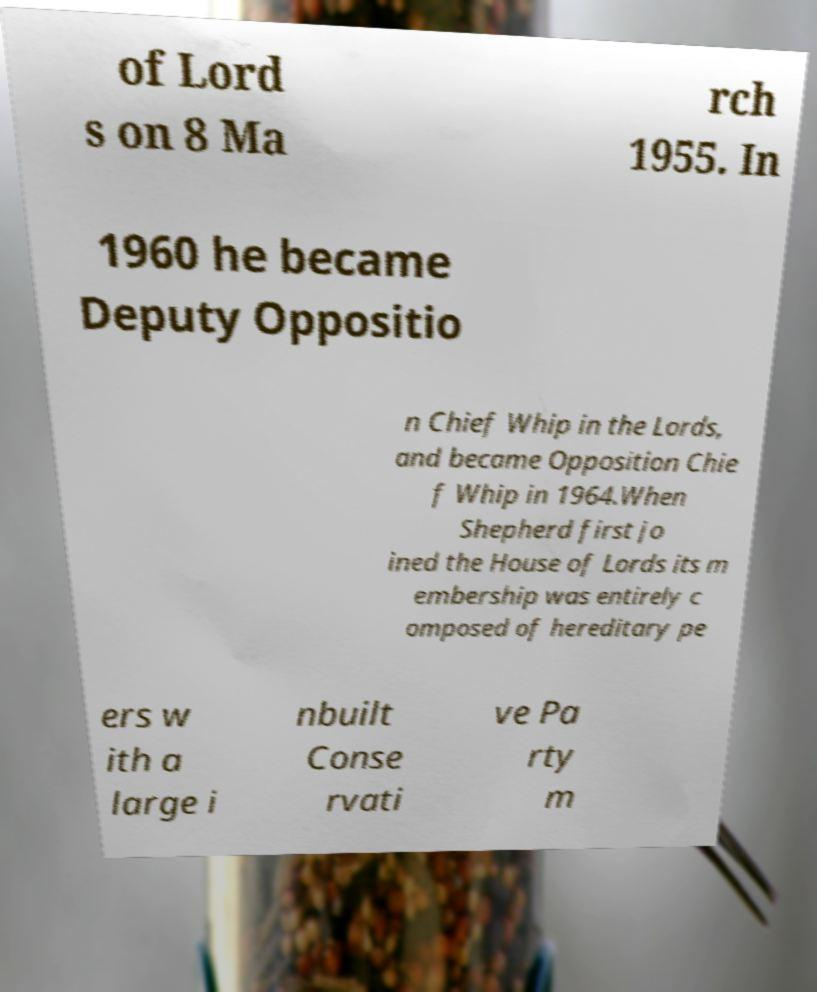Please read and relay the text visible in this image. What does it say? of Lord s on 8 Ma rch 1955. In 1960 he became Deputy Oppositio n Chief Whip in the Lords, and became Opposition Chie f Whip in 1964.When Shepherd first jo ined the House of Lords its m embership was entirely c omposed of hereditary pe ers w ith a large i nbuilt Conse rvati ve Pa rty m 